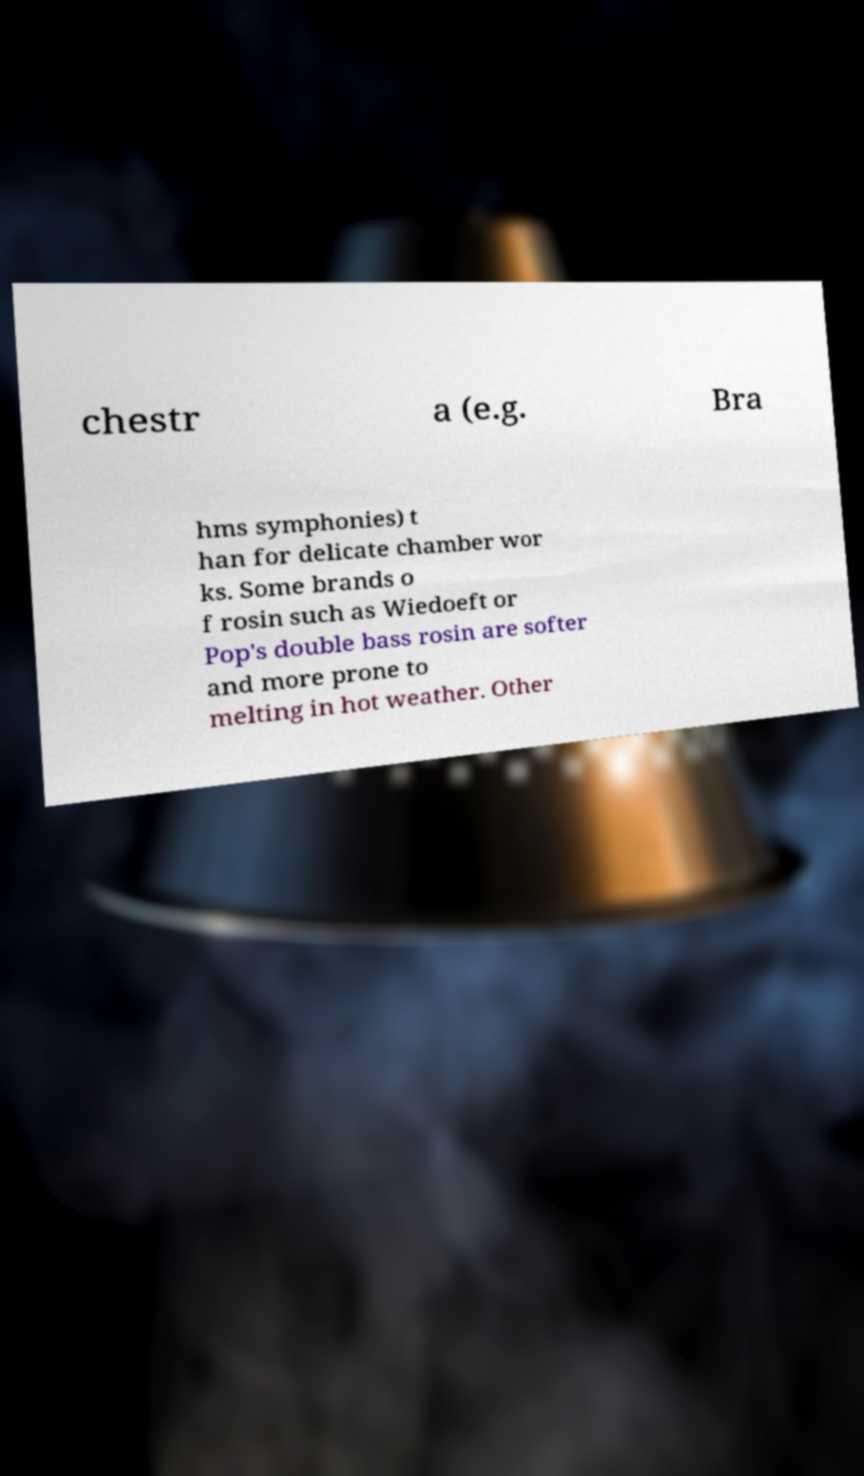Could you extract and type out the text from this image? chestr a (e.g. Bra hms symphonies) t han for delicate chamber wor ks. Some brands o f rosin such as Wiedoeft or Pop's double bass rosin are softer and more prone to melting in hot weather. Other 